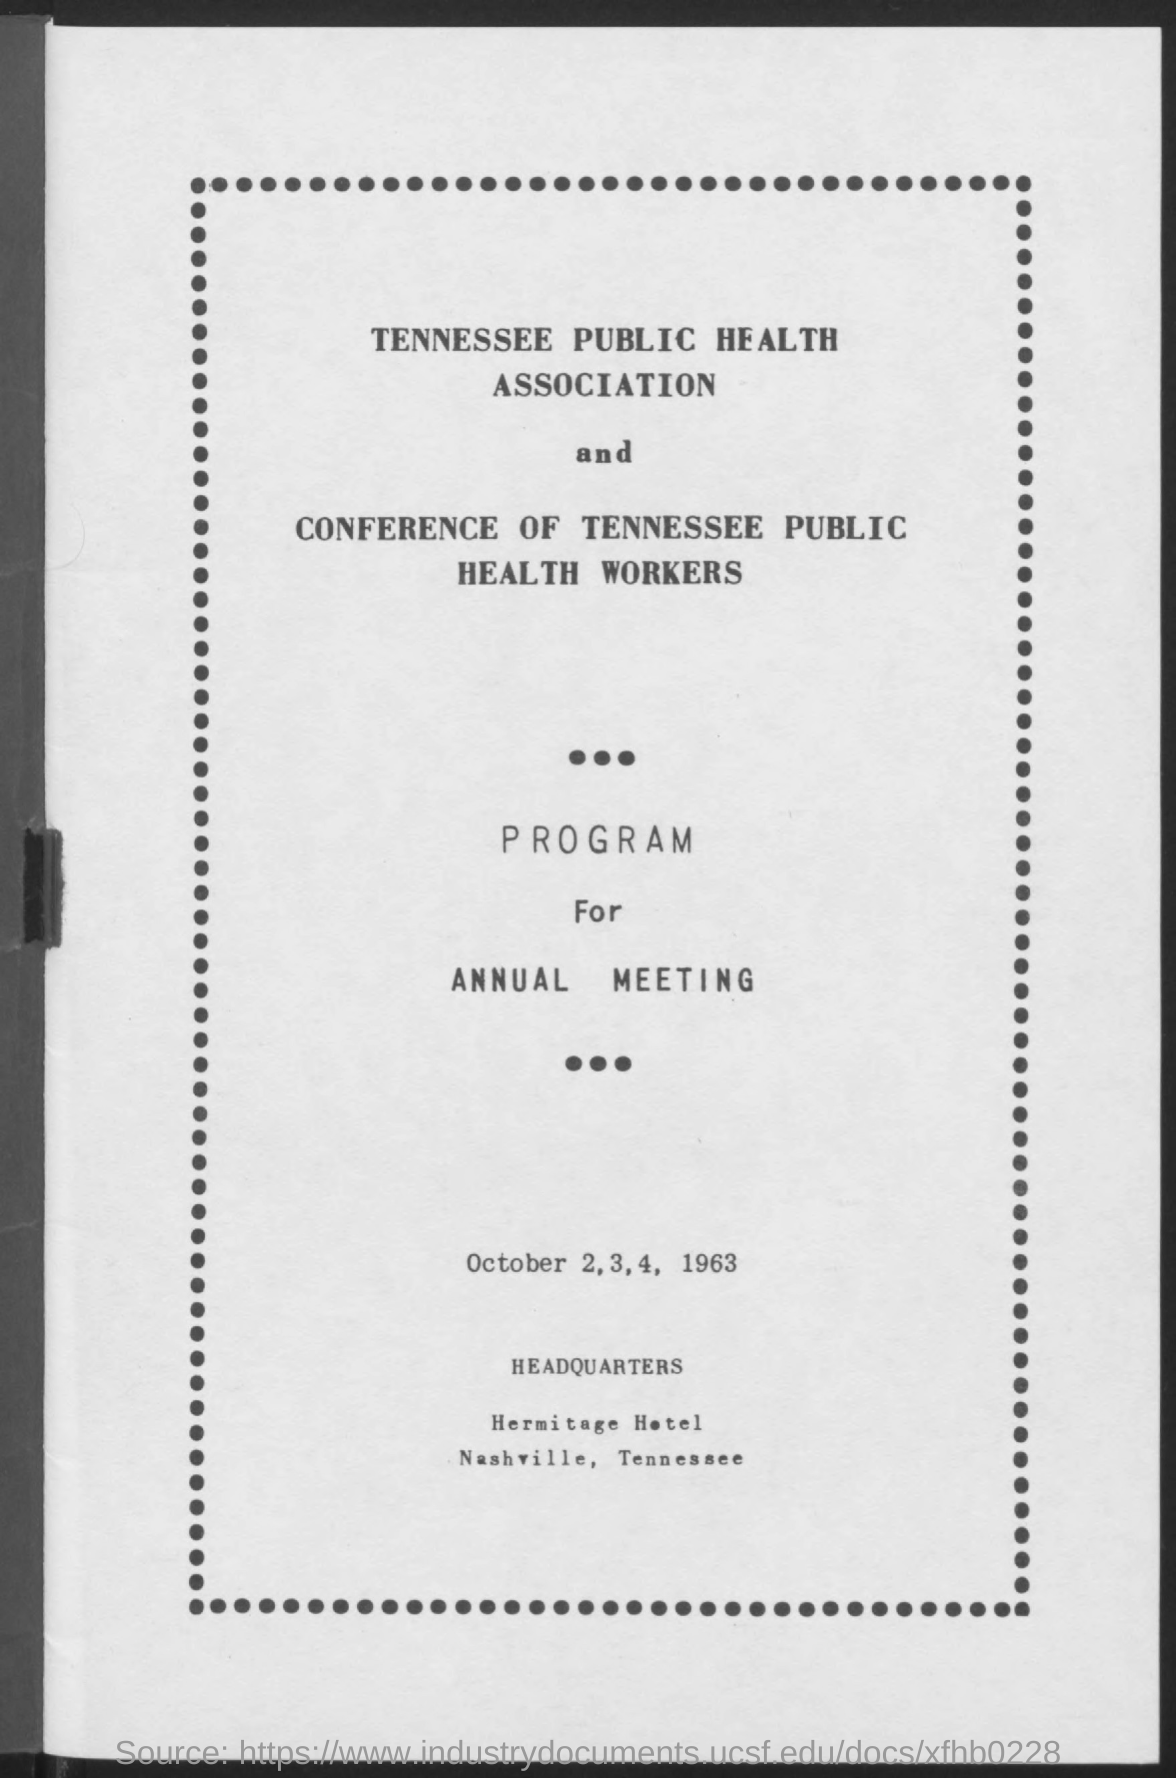List a handful of essential elements in this visual. The annual meeting will take place on October 2, 3, and 4, 1963. The location of the event is the Hermitage Hotel in Nashville, Tennessee. 